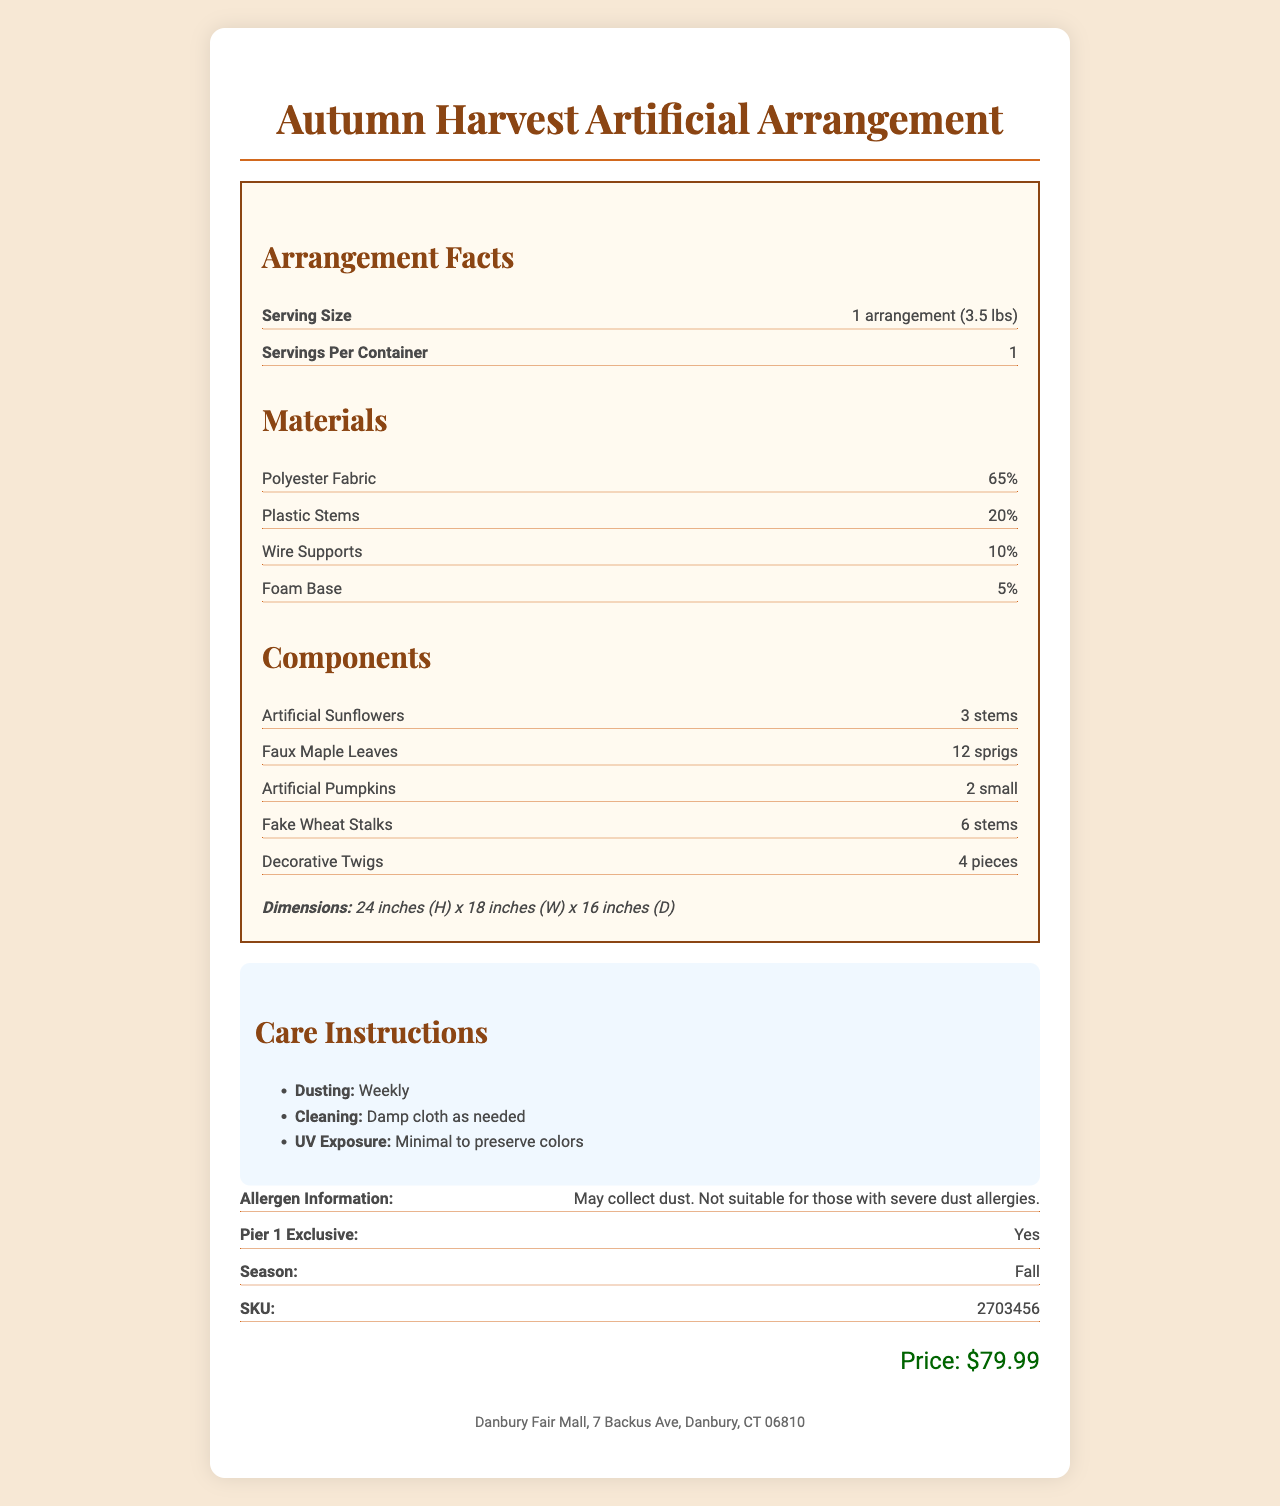how much does the Autumn Harvest Artificial Arrangement weigh? The serving size mentioned in the document is "1 arrangement (3.5 lbs)," which indicates the weight of the arrangement.
Answer: 3.5 lbs What materials are used in the artificial arrangement? The document lists the materials as Polyester Fabric (65%), Plastic Stems (20%), Wire Supports (10%), and Foam Base (5%).
Answer: Polyester Fabric, Plastic Stems, Wire Supports, Foam Base How often should the arrangement be dusted? Under "Care Instructions," it specifies that dusting should be done weekly.
Answer: Weekly What are the dimensions of the arrangement? The dimensions are given under the "Dimensions" section: 24 inches Height, 18 inches Width, 16 inches Depth.
Answer: 24 inches (H) x 18 inches (W) x 16 inches (D) What store location is this product found at? The store location is specified at the bottom of the document.
Answer: Danbury Fair Mall, 7 Backus Ave, Danbury, CT 06810 Which of the following is NOT a component of the arrangement? A. Artificial Sunflowers B. Faux Maple Leaves C. Real Flowers D. Decorative Twigs The document lists Artificial Sunflowers, Faux Maple Leaves, Artificial Pumpkins, Fake Wheat Stalks, and Decorative Twigs as components, but not Real Flowers.
Answer: C How many artificial sunflowers are included in the arrangement? The components section mentions that the arrangement includes 3 stems of Artificial Sunflowers.
Answer: 3 stems Is the Autumn Harvest Artificial Arrangement a Pier 1 exclusive? The document states "Pier 1 Exclusive: Yes."
Answer: Yes What is the price of the Autumn Harvest Artificial Arrangement? The price is listed as $79.99 in the document.
Answer: $79.99 What is a potential issue for someone with severe dust allergies? The allergen information section indicates that the product may collect dust and is not suitable for those with severe dust allergies.
Answer: May collect dust. Not suitable for those with severe dust allergies. What season is the Autumn Harvest Artificial Arrangement designed for? The document specifies that the arrangement is for the fall season.
Answer: Fall Does the arrangement need protection from UV exposure? A. No B. Minimal C. Moderate D. High The care instructions mention that minimal UV exposure is recommended to preserve the colors.
Answer: B Can you find out the arrangement's manufacturer from the document? The document does not provide any information about the manufacturer of the arrangement.
Answer: Not enough information Describe the Autumn Harvest Artificial Arrangement document. The document provides comprehensive information about the product, including its physical attributes, care guidelines, and purchase details. It is visually structured with sections for each type of information, making it easy to understand.
Answer: The document details the Autumn Harvest Artificial Arrangement, outlining its weight, dimensions, materials, and components. It includes care instructions and allergen information, specifies its exclusivity to Pier 1, and provides its price and store location. The document has a detailed and structured format to present this information. 